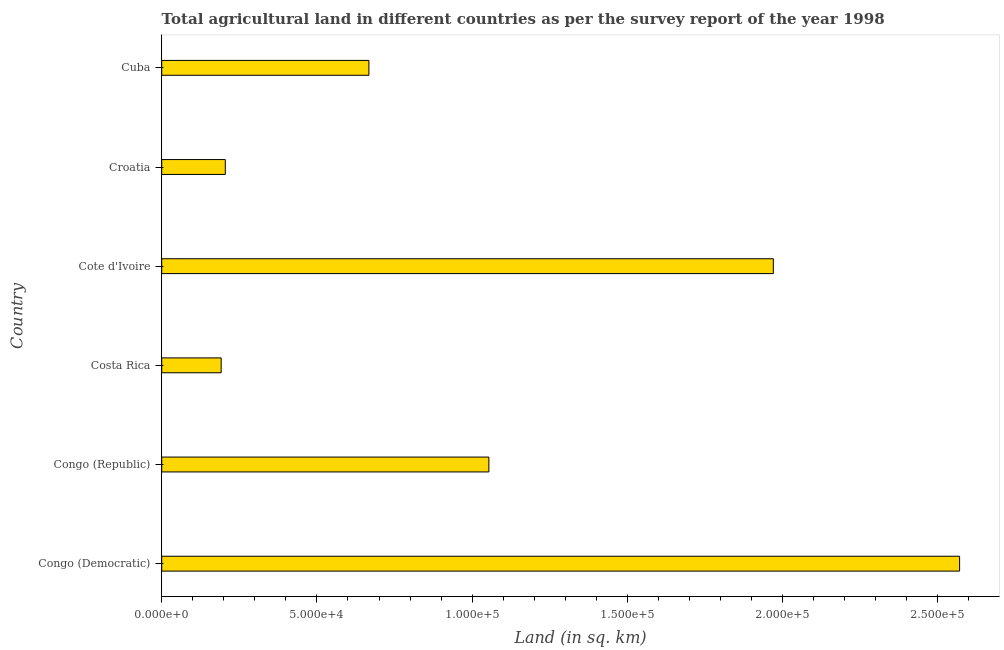Does the graph contain any zero values?
Offer a very short reply. No. Does the graph contain grids?
Your response must be concise. No. What is the title of the graph?
Make the answer very short. Total agricultural land in different countries as per the survey report of the year 1998. What is the label or title of the X-axis?
Make the answer very short. Land (in sq. km). What is the agricultural land in Costa Rica?
Your response must be concise. 1.92e+04. Across all countries, what is the maximum agricultural land?
Your response must be concise. 2.57e+05. Across all countries, what is the minimum agricultural land?
Make the answer very short. 1.92e+04. In which country was the agricultural land maximum?
Give a very brief answer. Congo (Democratic). In which country was the agricultural land minimum?
Ensure brevity in your answer.  Costa Rica. What is the sum of the agricultural land?
Provide a short and direct response. 6.66e+05. What is the difference between the agricultural land in Congo (Democratic) and Croatia?
Give a very brief answer. 2.37e+05. What is the average agricultural land per country?
Your answer should be very brief. 1.11e+05. What is the median agricultural land?
Offer a very short reply. 8.61e+04. What is the ratio of the agricultural land in Congo (Republic) to that in Cote d'Ivoire?
Give a very brief answer. 0.54. Is the agricultural land in Congo (Democratic) less than that in Cuba?
Keep it short and to the point. No. Is the difference between the agricultural land in Costa Rica and Croatia greater than the difference between any two countries?
Give a very brief answer. No. What is the difference between the highest and the lowest agricultural land?
Your response must be concise. 2.38e+05. In how many countries, is the agricultural land greater than the average agricultural land taken over all countries?
Offer a very short reply. 2. How many bars are there?
Make the answer very short. 6. Are all the bars in the graph horizontal?
Make the answer very short. Yes. What is the difference between two consecutive major ticks on the X-axis?
Provide a short and direct response. 5.00e+04. What is the Land (in sq. km) in Congo (Democratic)?
Provide a short and direct response. 2.57e+05. What is the Land (in sq. km) in Congo (Republic)?
Provide a succinct answer. 1.05e+05. What is the Land (in sq. km) in Costa Rica?
Give a very brief answer. 1.92e+04. What is the Land (in sq. km) of Cote d'Ivoire?
Offer a very short reply. 1.97e+05. What is the Land (in sq. km) in Croatia?
Keep it short and to the point. 2.05e+04. What is the Land (in sq. km) of Cuba?
Give a very brief answer. 6.67e+04. What is the difference between the Land (in sq. km) in Congo (Democratic) and Congo (Republic)?
Your answer should be compact. 1.52e+05. What is the difference between the Land (in sq. km) in Congo (Democratic) and Costa Rica?
Offer a terse response. 2.38e+05. What is the difference between the Land (in sq. km) in Congo (Democratic) and Croatia?
Your answer should be compact. 2.37e+05. What is the difference between the Land (in sq. km) in Congo (Democratic) and Cuba?
Keep it short and to the point. 1.90e+05. What is the difference between the Land (in sq. km) in Congo (Republic) and Costa Rica?
Your response must be concise. 8.62e+04. What is the difference between the Land (in sq. km) in Congo (Republic) and Cote d'Ivoire?
Your response must be concise. -9.16e+04. What is the difference between the Land (in sq. km) in Congo (Republic) and Croatia?
Give a very brief answer. 8.49e+04. What is the difference between the Land (in sq. km) in Congo (Republic) and Cuba?
Keep it short and to the point. 3.86e+04. What is the difference between the Land (in sq. km) in Costa Rica and Cote d'Ivoire?
Your answer should be very brief. -1.78e+05. What is the difference between the Land (in sq. km) in Costa Rica and Croatia?
Your answer should be very brief. -1330. What is the difference between the Land (in sq. km) in Costa Rica and Cuba?
Your response must be concise. -4.76e+04. What is the difference between the Land (in sq. km) in Cote d'Ivoire and Croatia?
Offer a very short reply. 1.77e+05. What is the difference between the Land (in sq. km) in Cote d'Ivoire and Cuba?
Offer a very short reply. 1.30e+05. What is the difference between the Land (in sq. km) in Croatia and Cuba?
Provide a succinct answer. -4.63e+04. What is the ratio of the Land (in sq. km) in Congo (Democratic) to that in Congo (Republic)?
Offer a terse response. 2.44. What is the ratio of the Land (in sq. km) in Congo (Democratic) to that in Costa Rica?
Your answer should be compact. 13.42. What is the ratio of the Land (in sq. km) in Congo (Democratic) to that in Cote d'Ivoire?
Provide a succinct answer. 1.3. What is the ratio of the Land (in sq. km) in Congo (Democratic) to that in Croatia?
Give a very brief answer. 12.55. What is the ratio of the Land (in sq. km) in Congo (Democratic) to that in Cuba?
Keep it short and to the point. 3.85. What is the ratio of the Land (in sq. km) in Congo (Republic) to that in Costa Rica?
Keep it short and to the point. 5.5. What is the ratio of the Land (in sq. km) in Congo (Republic) to that in Cote d'Ivoire?
Your response must be concise. 0.54. What is the ratio of the Land (in sq. km) in Congo (Republic) to that in Croatia?
Your answer should be very brief. 5.15. What is the ratio of the Land (in sq. km) in Congo (Republic) to that in Cuba?
Your answer should be compact. 1.58. What is the ratio of the Land (in sq. km) in Costa Rica to that in Cote d'Ivoire?
Offer a terse response. 0.1. What is the ratio of the Land (in sq. km) in Costa Rica to that in Croatia?
Ensure brevity in your answer.  0.94. What is the ratio of the Land (in sq. km) in Costa Rica to that in Cuba?
Your answer should be very brief. 0.29. What is the ratio of the Land (in sq. km) in Cote d'Ivoire to that in Croatia?
Your response must be concise. 9.62. What is the ratio of the Land (in sq. km) in Cote d'Ivoire to that in Cuba?
Keep it short and to the point. 2.95. What is the ratio of the Land (in sq. km) in Croatia to that in Cuba?
Provide a short and direct response. 0.31. 